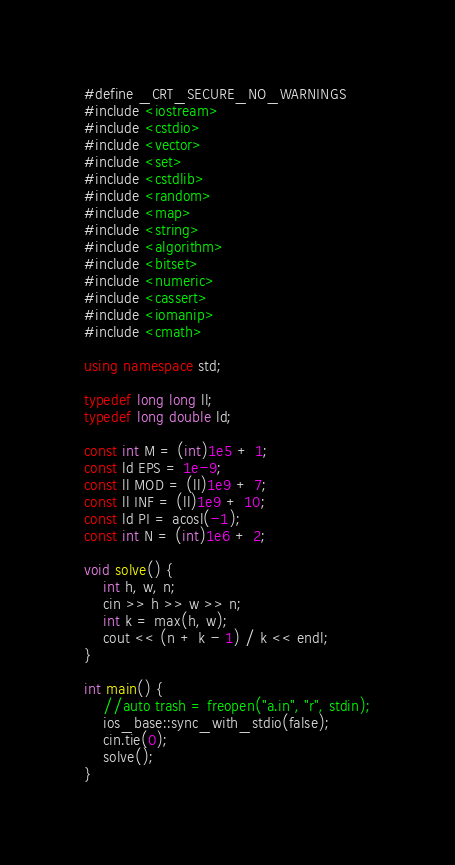Convert code to text. <code><loc_0><loc_0><loc_500><loc_500><_C++_>#define _CRT_SECURE_NO_WARNINGS
#include <iostream>
#include <cstdio>
#include <vector>
#include <set>
#include <cstdlib>
#include <random>
#include <map>
#include <string>
#include <algorithm>
#include <bitset>
#include <numeric>
#include <cassert>
#include <iomanip>
#include <cmath>

using namespace std;

typedef long long ll;
typedef long double ld;

const int M = (int)1e5 + 1;
const ld EPS = 1e-9;
const ll MOD = (ll)1e9 + 7;
const ll INF = (ll)1e9 + 10;
const ld PI = acosl(-1);
const int N = (int)1e6 + 2;

void solve() {
	int h, w, n;
	cin >> h >> w >> n;
	int k = max(h, w);
	cout << (n + k - 1) / k << endl;
}

int main() {
	//auto trash = freopen("a.in", "r", stdin);
	ios_base::sync_with_stdio(false);
	cin.tie(0);
	solve();
}</code> 